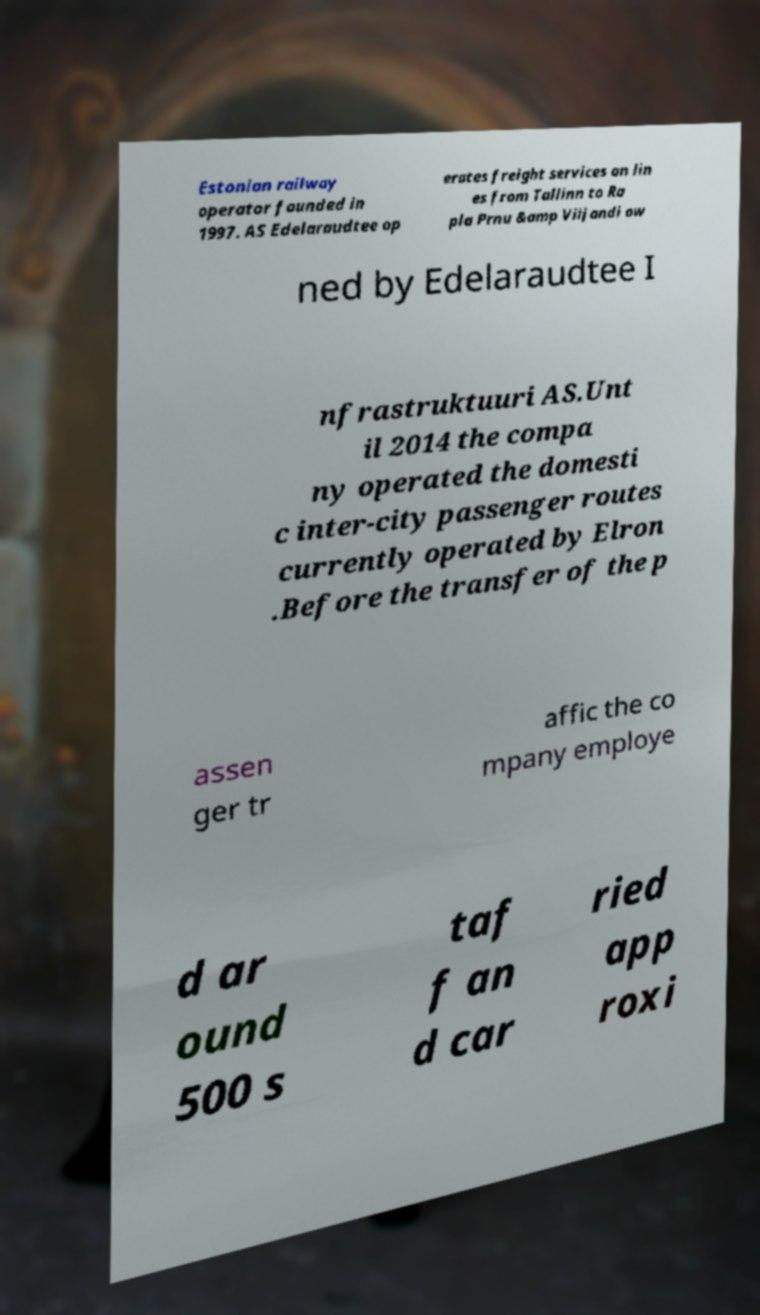For documentation purposes, I need the text within this image transcribed. Could you provide that? Estonian railway operator founded in 1997. AS Edelaraudtee op erates freight services on lin es from Tallinn to Ra pla Prnu &amp Viljandi ow ned by Edelaraudtee I nfrastruktuuri AS.Unt il 2014 the compa ny operated the domesti c inter-city passenger routes currently operated by Elron .Before the transfer of the p assen ger tr affic the co mpany employe d ar ound 500 s taf f an d car ried app roxi 